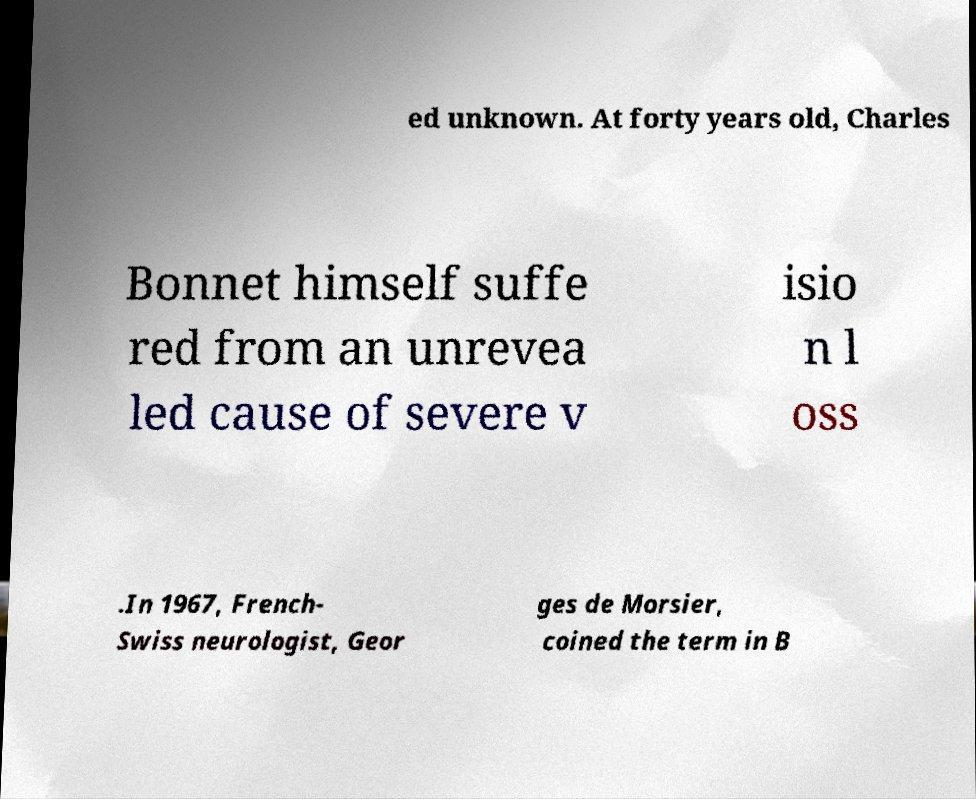Can you read and provide the text displayed in the image?This photo seems to have some interesting text. Can you extract and type it out for me? ed unknown. At forty years old, Charles Bonnet himself suffe red from an unrevea led cause of severe v isio n l oss .In 1967, French- Swiss neurologist, Geor ges de Morsier, coined the term in B 